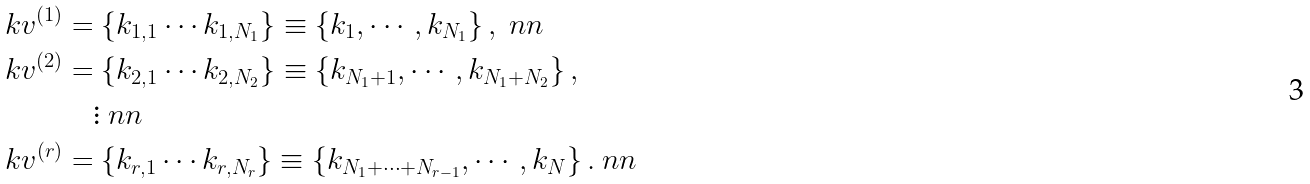<formula> <loc_0><loc_0><loc_500><loc_500>\ k v ^ { ( 1 ) } & = \left \{ k _ { 1 , 1 } \cdots k _ { 1 , N _ { 1 } } \right \} \equiv \left \{ k _ { 1 } , \cdots , k _ { N _ { 1 } } \right \} , \ n n \\ \ k v ^ { ( 2 ) } & = \left \{ k _ { 2 , 1 } \cdots k _ { 2 , N _ { 2 } } \right \} \equiv \left \{ k _ { N _ { 1 } + 1 } , \cdots , k _ { N _ { 1 } + N _ { 2 } } \right \} , \\ & \quad \vdots \ n n \\ \ k v ^ { ( r ) } & = \left \{ k _ { r , 1 } \cdots k _ { r , N _ { r } } \right \} \equiv \left \{ k _ { N _ { 1 } + \cdots + N _ { r - 1 } } , \cdots , k _ { N } \right \} . \ n n</formula> 